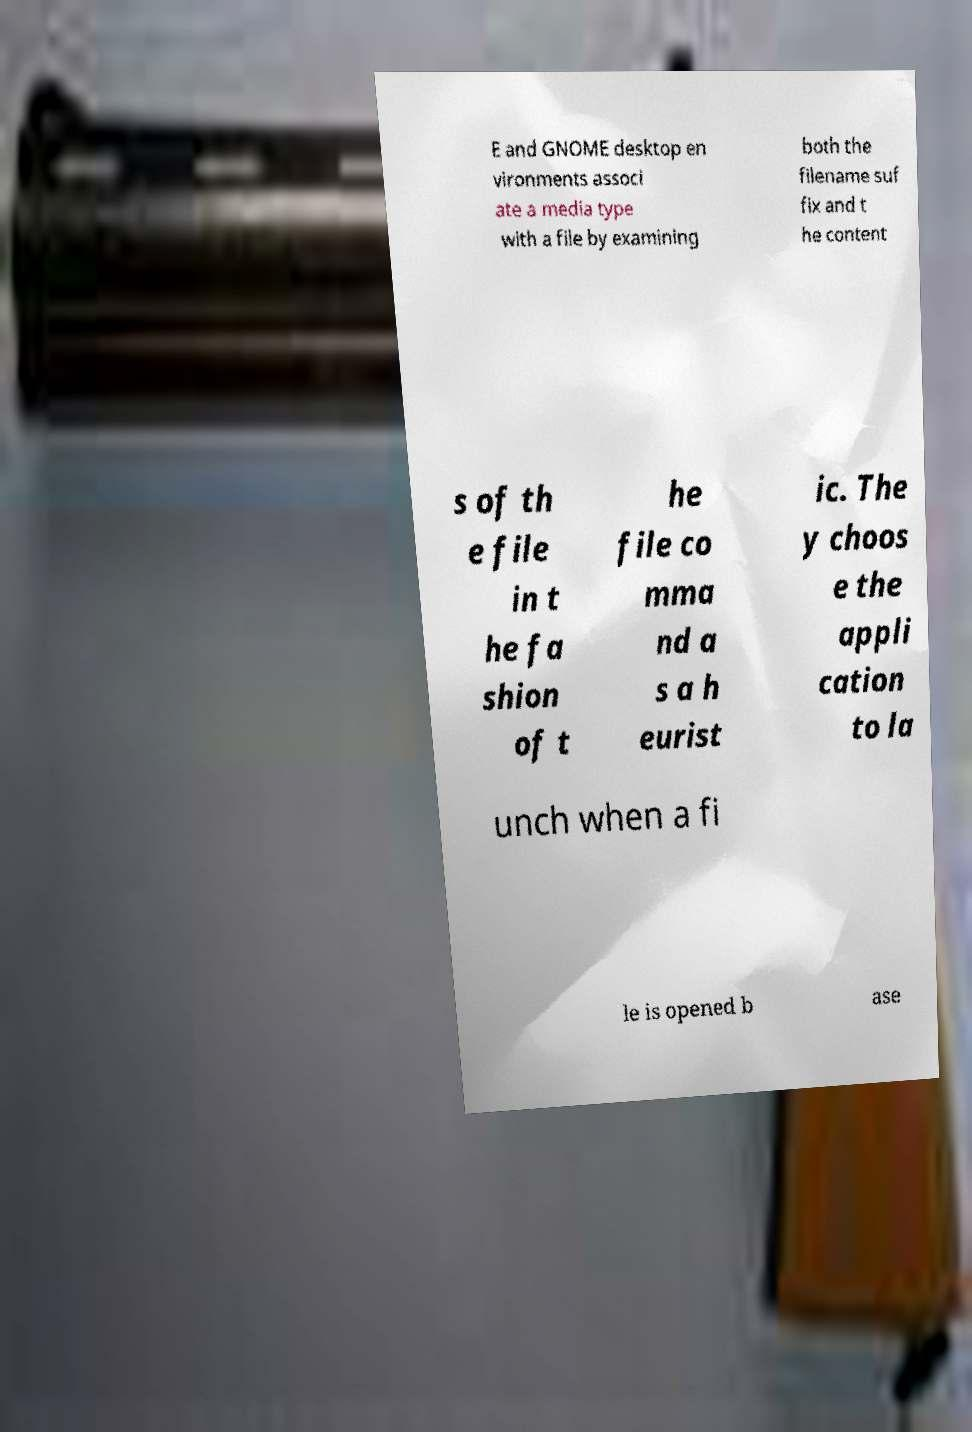Could you extract and type out the text from this image? E and GNOME desktop en vironments associ ate a media type with a file by examining both the filename suf fix and t he content s of th e file in t he fa shion of t he file co mma nd a s a h eurist ic. The y choos e the appli cation to la unch when a fi le is opened b ase 